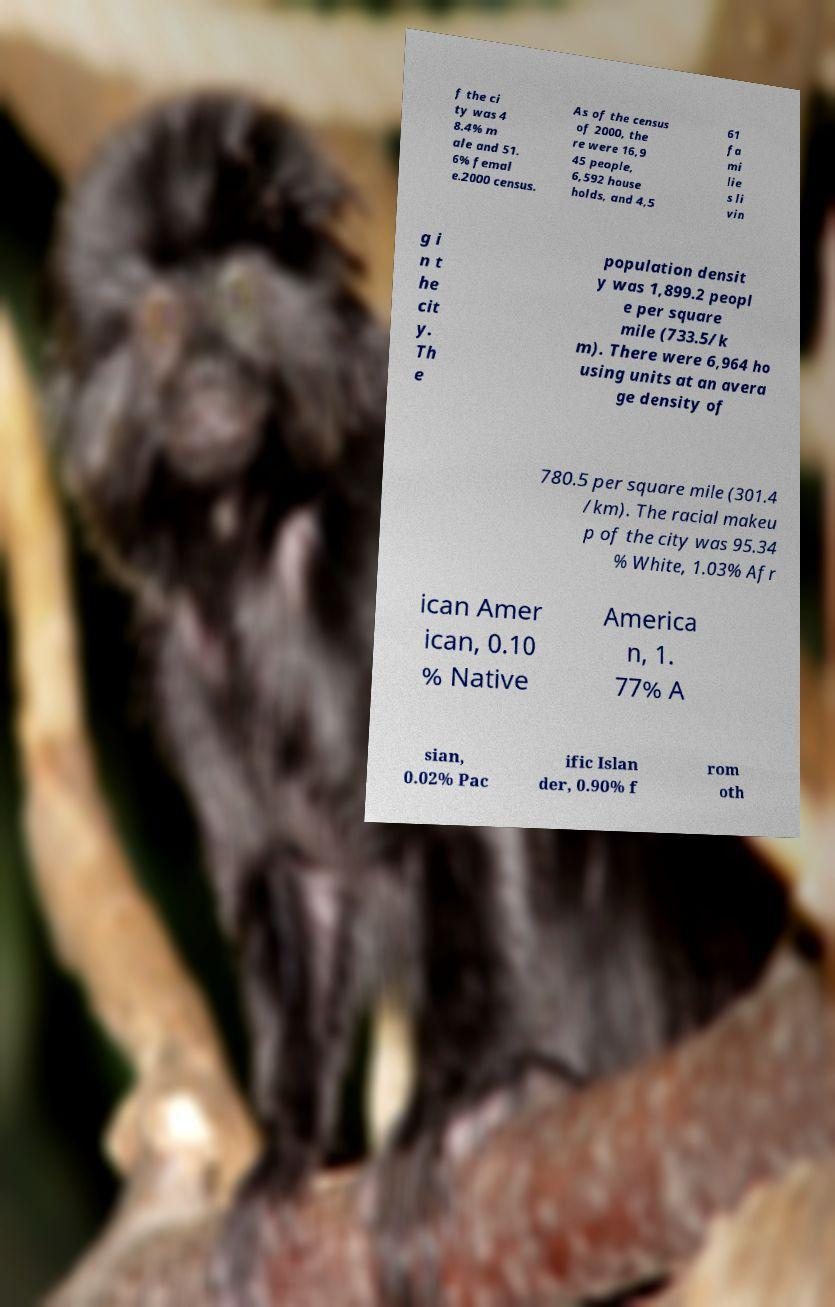Please read and relay the text visible in this image. What does it say? f the ci ty was 4 8.4% m ale and 51. 6% femal e.2000 census. As of the census of 2000, the re were 16,9 45 people, 6,592 house holds, and 4,5 61 fa mi lie s li vin g i n t he cit y. Th e population densit y was 1,899.2 peopl e per square mile (733.5/k m). There were 6,964 ho using units at an avera ge density of 780.5 per square mile (301.4 /km). The racial makeu p of the city was 95.34 % White, 1.03% Afr ican Amer ican, 0.10 % Native America n, 1. 77% A sian, 0.02% Pac ific Islan der, 0.90% f rom oth 